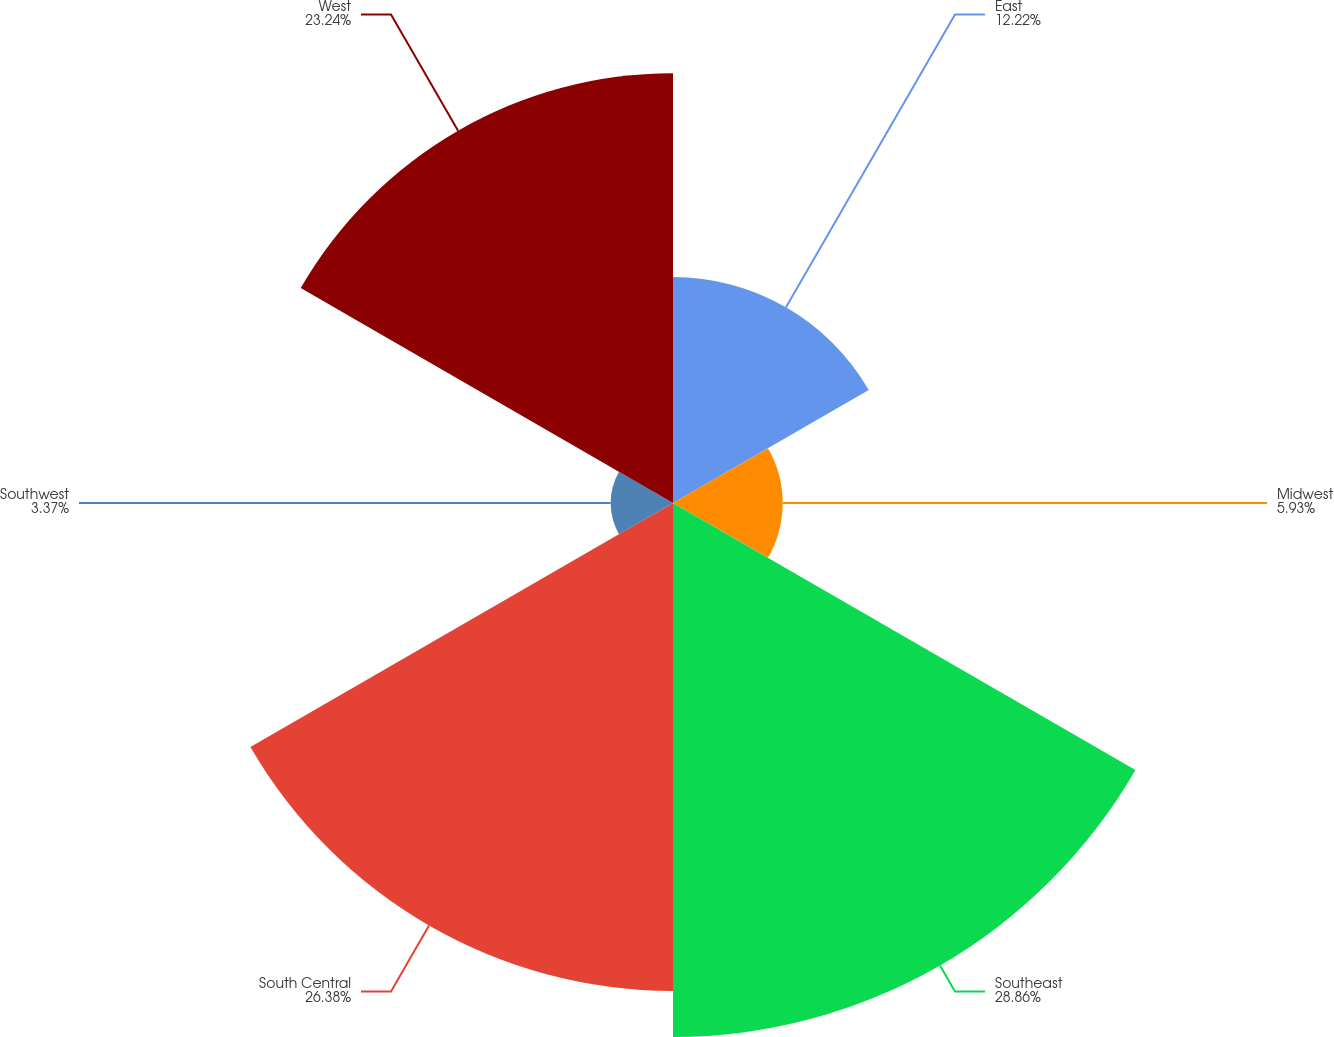<chart> <loc_0><loc_0><loc_500><loc_500><pie_chart><fcel>East<fcel>Midwest<fcel>Southeast<fcel>South Central<fcel>Southwest<fcel>West<nl><fcel>12.22%<fcel>5.93%<fcel>28.87%<fcel>26.38%<fcel>3.37%<fcel>23.24%<nl></chart> 